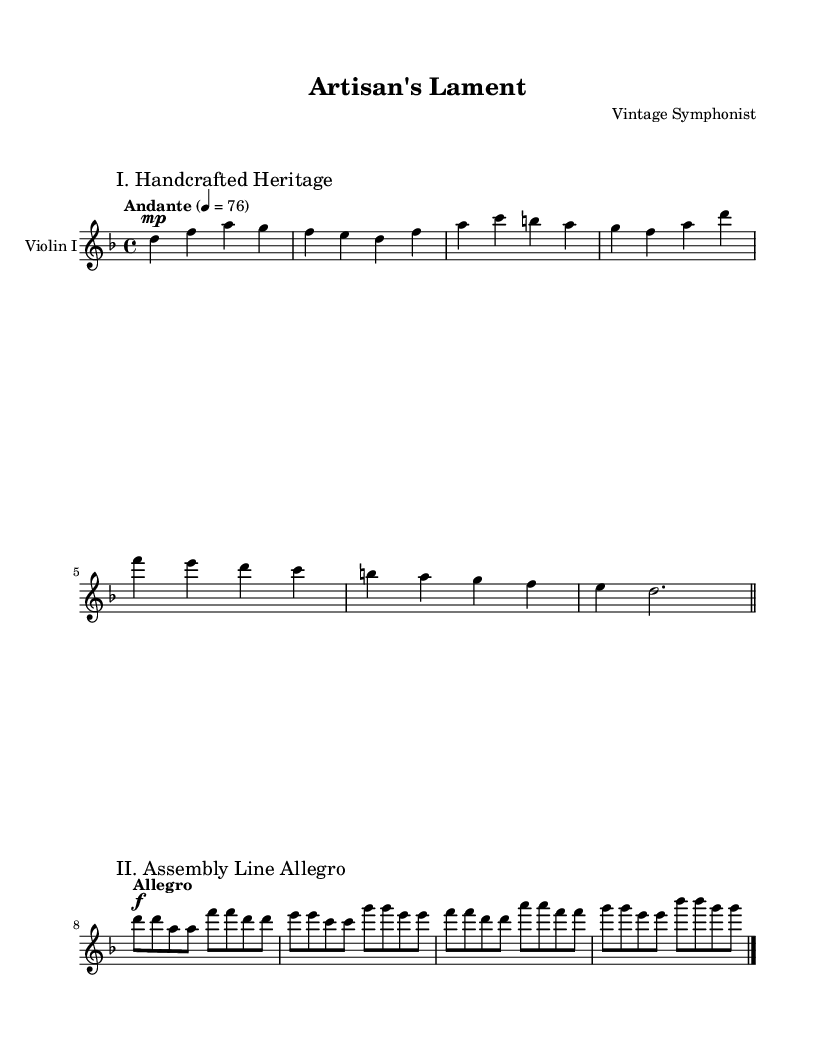What is the key signature of this music? The key signature is indicated at the beginning of the sheet music, and there is one flat, which corresponds to D minor.
Answer: D minor What is the time signature of this music? The time signature is displayed at the beginning of the sheet music, showing it is in 4/4 time, which means there are four beats in each measure.
Answer: 4/4 What is the tempo marking for the first movement? The tempo marking for the first movement is placed above the notation and indicates "Andante," suggesting a moderately slow pace.
Answer: Andante How many measures are in the first movement? Counting the measures marked in the first movement, I find a total of eight measures, as displayed before the double bar line.
Answer: Eight What dynamic marking is used at the beginning of the first movement? The dynamic marking at the beginning of the first movement is "mp," which stands for mezzo-piano, indicating a moderately soft sound level.
Answer: mezzo-piano What is the tempo marking for the second movement? The second movement indicates "Allegro," which suggests a brisk and lively pace, contrasting the first movement.
Answer: Allegro What is the title of the second movement? The title is marked above the staff within the music, clearly indicating it as "II. Assembly Line Allegro."
Answer: II. Assembly Line Allegro 